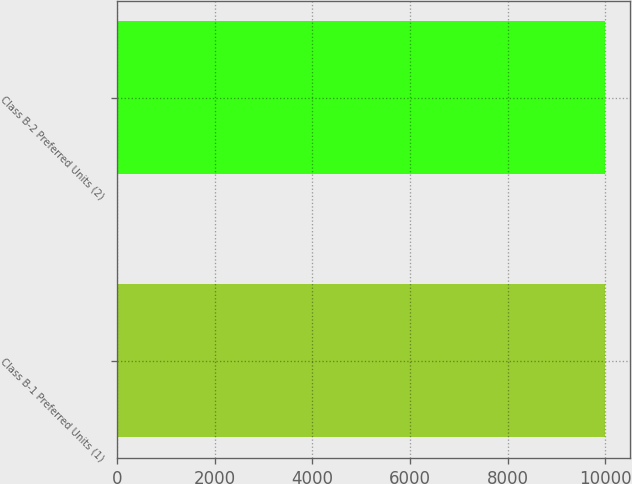Convert chart. <chart><loc_0><loc_0><loc_500><loc_500><bar_chart><fcel>Class B-1 Preferred Units (1)<fcel>Class B-2 Preferred Units (2)<nl><fcel>10000<fcel>10000.1<nl></chart> 